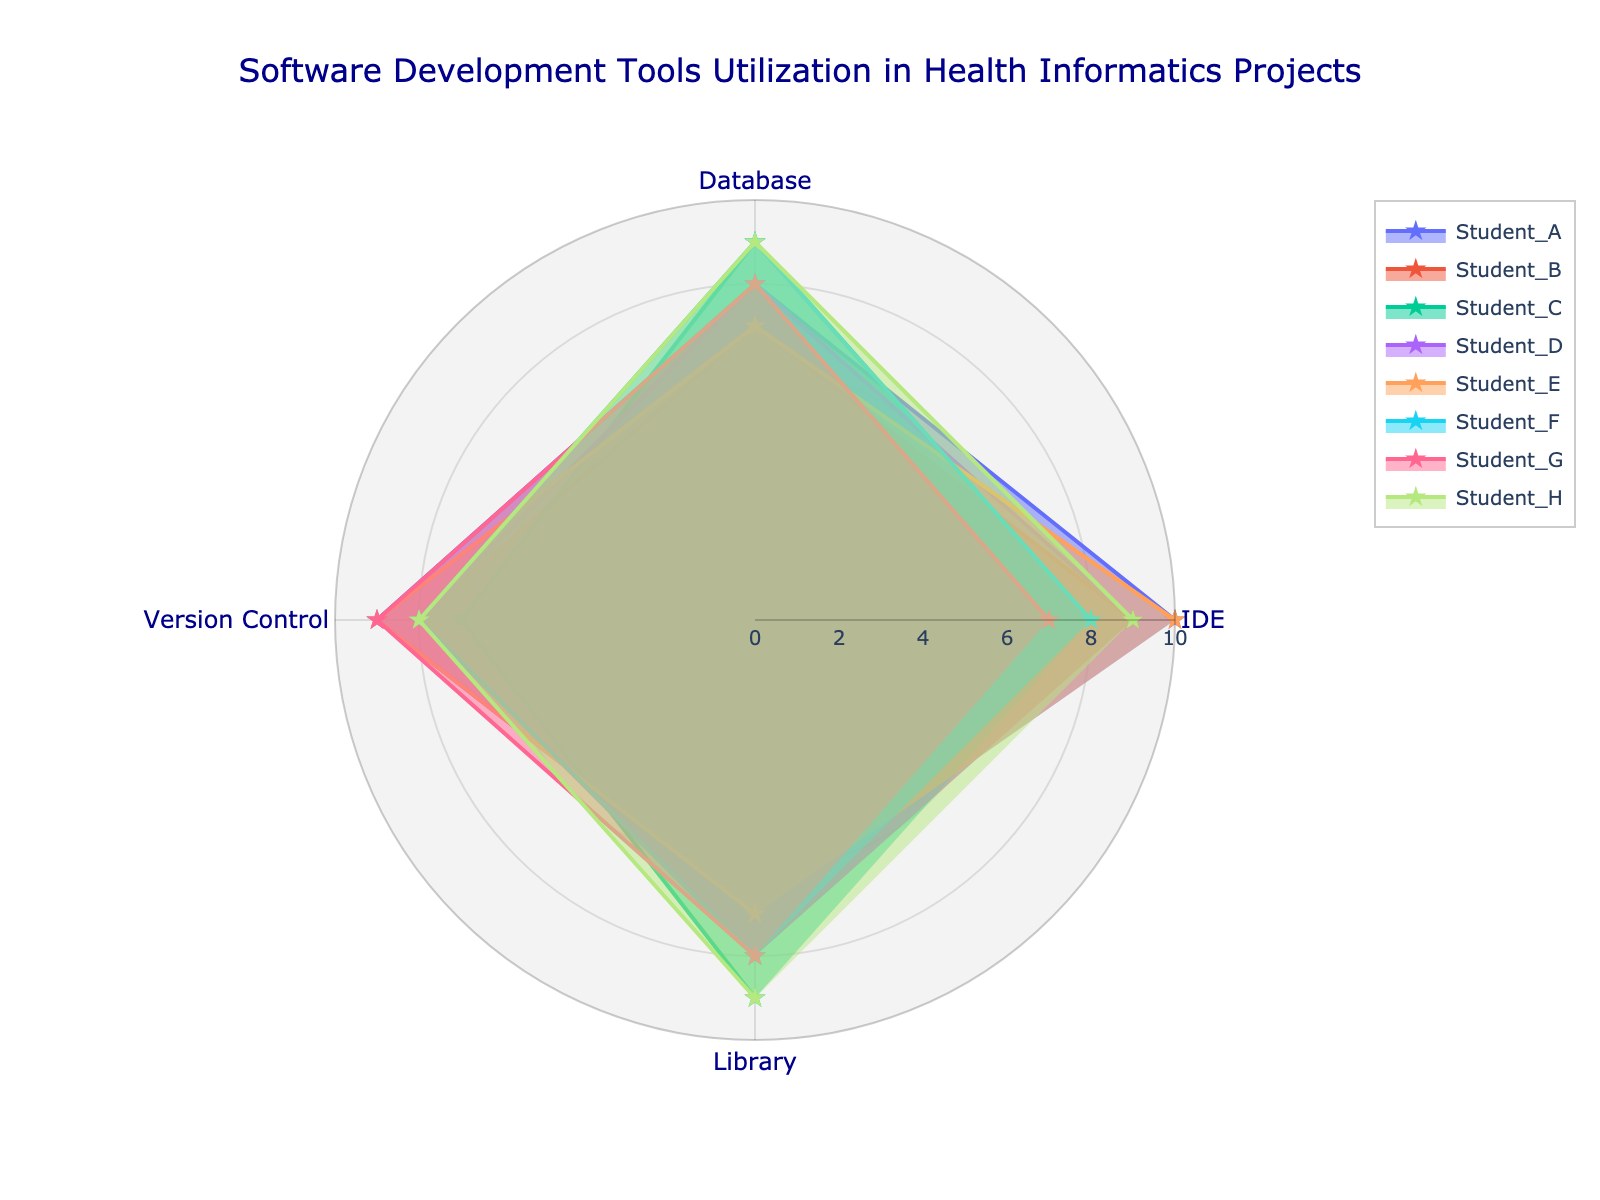What is the title of the radar chart? The title is positioned at the top center of the chart. The text indicates the overall theme of the chart.
Answer: Software Development Tools Utilization in Health Informatics Projects What is the maximum rating for the categories in the radar chart? Each axis in the radar chart ranges from 0 to a maximum value. By observing the radial axis labels, we can identify this value.
Answer: 10 How many students' data are represented in the radar chart? The chart legend lists the different names symbolizing each student's data. By counting these items, we can determine the total number of students.
Answer: 8 Which student has the highest rating for 'IDE'? Examine the values along the 'IDE' axis for all students and identify the one with the highest rating.
Answer: Student_A and Student_E What is the average rating for 'Version Control'? Summing the 'Version Control' ratings for all students and then dividing by the total number of students gives the average rating. Calculation: (9 + 8 + 7 + 8 + 9 + 8 + 9 + 8) / 8
Answer: 8.25 Which student has the lowest rating for 'Database'? Look at the values along the 'Database' axis and find the student with the lowest rating.
Answer: Student_E and Student_B How does Student_H's utilization in 'Library' compare to Student_C's? Compare the values of the 'Library' category for Student_H and Student_C to see which is higher, lower, or if they are equal.
Answer: Equal Which category shows the highest variability in ratings among students? By visually comparing the spread or range of values for each category, identify which one shows the most variation.
Answer: Library Who has similar utilization patterns to Student_D in terms of all categories? Look for another student's data that roughly aligns with Student_D's data points across all categories.
Answer: Student_B and Student_F What is the median rating for 'Database' among all students? Arrange all 'Database' ratings in ascending order and identify the middle value (or the average of two middle values if the number of students is even). Ratings are: 7, 7, 8, 8, 8, 9, 9, 9.
Answer: 8 